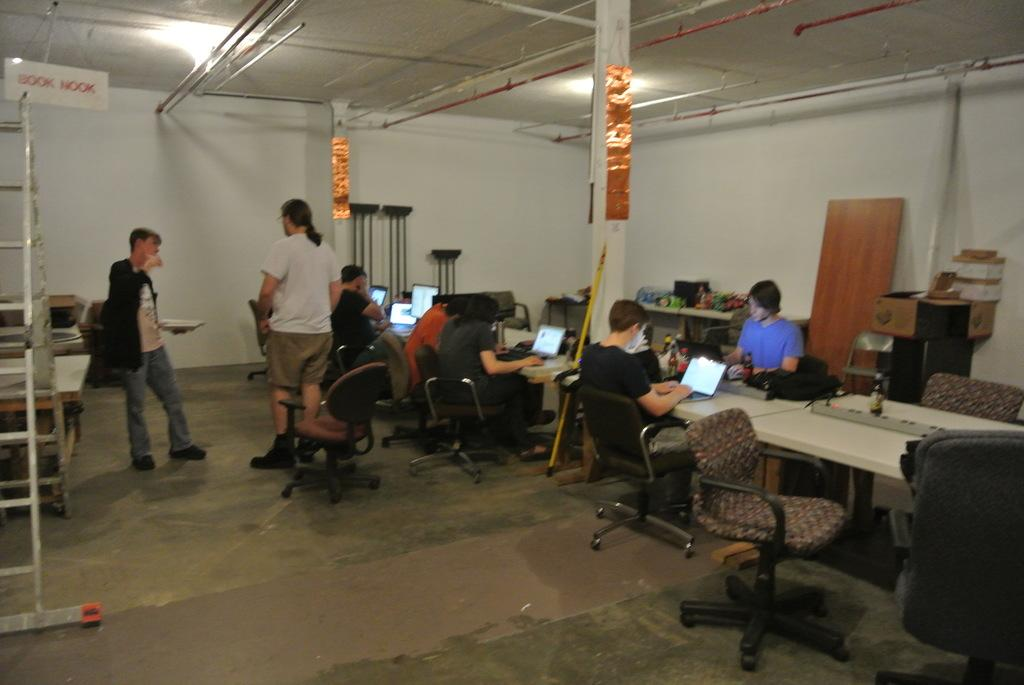What is the color of the wall in the image? There is a white color wall in the image. What are the people in the image doing? The people in the image are standing and sitting. What type of furniture is present in the image? There are chairs in the image. What is on the table in the image? There are laptops on the table. Is there a list of items that people need to bring to the bridge in the image? There is no mention of a bridge or a list of items in the image. 